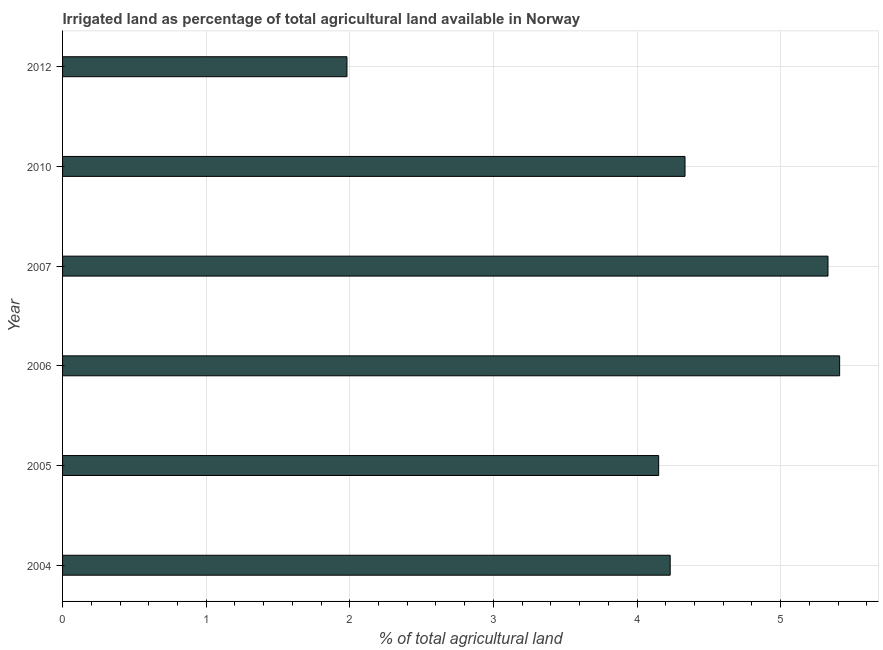Does the graph contain any zero values?
Keep it short and to the point. No. What is the title of the graph?
Give a very brief answer. Irrigated land as percentage of total agricultural land available in Norway. What is the label or title of the X-axis?
Keep it short and to the point. % of total agricultural land. What is the percentage of agricultural irrigated land in 2006?
Offer a terse response. 5.41. Across all years, what is the maximum percentage of agricultural irrigated land?
Ensure brevity in your answer.  5.41. Across all years, what is the minimum percentage of agricultural irrigated land?
Provide a succinct answer. 1.98. In which year was the percentage of agricultural irrigated land minimum?
Your answer should be compact. 2012. What is the sum of the percentage of agricultural irrigated land?
Your answer should be very brief. 25.44. What is the difference between the percentage of agricultural irrigated land in 2007 and 2012?
Ensure brevity in your answer.  3.35. What is the average percentage of agricultural irrigated land per year?
Give a very brief answer. 4.24. What is the median percentage of agricultural irrigated land?
Offer a very short reply. 4.28. What is the ratio of the percentage of agricultural irrigated land in 2005 to that in 2012?
Make the answer very short. 2.1. Is the percentage of agricultural irrigated land in 2006 less than that in 2010?
Provide a succinct answer. No. Is the difference between the percentage of agricultural irrigated land in 2004 and 2006 greater than the difference between any two years?
Offer a very short reply. No. What is the difference between the highest and the second highest percentage of agricultural irrigated land?
Provide a short and direct response. 0.08. Is the sum of the percentage of agricultural irrigated land in 2005 and 2006 greater than the maximum percentage of agricultural irrigated land across all years?
Ensure brevity in your answer.  Yes. What is the difference between the highest and the lowest percentage of agricultural irrigated land?
Keep it short and to the point. 3.43. In how many years, is the percentage of agricultural irrigated land greater than the average percentage of agricultural irrigated land taken over all years?
Provide a succinct answer. 3. How many bars are there?
Ensure brevity in your answer.  6. How many years are there in the graph?
Make the answer very short. 6. What is the difference between two consecutive major ticks on the X-axis?
Ensure brevity in your answer.  1. Are the values on the major ticks of X-axis written in scientific E-notation?
Keep it short and to the point. No. What is the % of total agricultural land in 2004?
Your answer should be very brief. 4.23. What is the % of total agricultural land of 2005?
Ensure brevity in your answer.  4.15. What is the % of total agricultural land in 2006?
Keep it short and to the point. 5.41. What is the % of total agricultural land in 2007?
Give a very brief answer. 5.33. What is the % of total agricultural land in 2010?
Offer a very short reply. 4.33. What is the % of total agricultural land in 2012?
Offer a terse response. 1.98. What is the difference between the % of total agricultural land in 2004 and 2005?
Ensure brevity in your answer.  0.08. What is the difference between the % of total agricultural land in 2004 and 2006?
Keep it short and to the point. -1.18. What is the difference between the % of total agricultural land in 2004 and 2007?
Keep it short and to the point. -1.1. What is the difference between the % of total agricultural land in 2004 and 2010?
Your response must be concise. -0.1. What is the difference between the % of total agricultural land in 2004 and 2012?
Offer a terse response. 2.25. What is the difference between the % of total agricultural land in 2005 and 2006?
Your answer should be very brief. -1.26. What is the difference between the % of total agricultural land in 2005 and 2007?
Ensure brevity in your answer.  -1.18. What is the difference between the % of total agricultural land in 2005 and 2010?
Keep it short and to the point. -0.18. What is the difference between the % of total agricultural land in 2005 and 2012?
Make the answer very short. 2.17. What is the difference between the % of total agricultural land in 2006 and 2007?
Make the answer very short. 0.08. What is the difference between the % of total agricultural land in 2006 and 2010?
Your answer should be very brief. 1.08. What is the difference between the % of total agricultural land in 2006 and 2012?
Offer a terse response. 3.43. What is the difference between the % of total agricultural land in 2007 and 2010?
Make the answer very short. 1. What is the difference between the % of total agricultural land in 2007 and 2012?
Your answer should be very brief. 3.35. What is the difference between the % of total agricultural land in 2010 and 2012?
Offer a very short reply. 2.35. What is the ratio of the % of total agricultural land in 2004 to that in 2005?
Give a very brief answer. 1.02. What is the ratio of the % of total agricultural land in 2004 to that in 2006?
Your answer should be compact. 0.78. What is the ratio of the % of total agricultural land in 2004 to that in 2007?
Your answer should be very brief. 0.79. What is the ratio of the % of total agricultural land in 2004 to that in 2010?
Offer a terse response. 0.98. What is the ratio of the % of total agricultural land in 2004 to that in 2012?
Your answer should be compact. 2.14. What is the ratio of the % of total agricultural land in 2005 to that in 2006?
Ensure brevity in your answer.  0.77. What is the ratio of the % of total agricultural land in 2005 to that in 2007?
Offer a very short reply. 0.78. What is the ratio of the % of total agricultural land in 2005 to that in 2010?
Your answer should be very brief. 0.96. What is the ratio of the % of total agricultural land in 2005 to that in 2012?
Give a very brief answer. 2.1. What is the ratio of the % of total agricultural land in 2006 to that in 2010?
Provide a short and direct response. 1.25. What is the ratio of the % of total agricultural land in 2006 to that in 2012?
Your answer should be very brief. 2.73. What is the ratio of the % of total agricultural land in 2007 to that in 2010?
Provide a succinct answer. 1.23. What is the ratio of the % of total agricultural land in 2007 to that in 2012?
Your response must be concise. 2.69. What is the ratio of the % of total agricultural land in 2010 to that in 2012?
Keep it short and to the point. 2.19. 